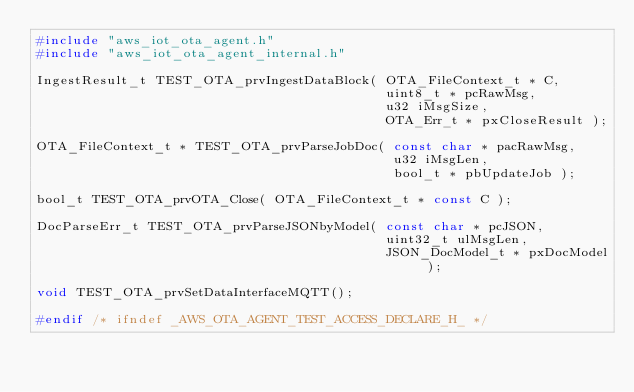Convert code to text. <code><loc_0><loc_0><loc_500><loc_500><_C_>#include "aws_iot_ota_agent.h"
#include "aws_iot_ota_agent_internal.h"

IngestResult_t TEST_OTA_prvIngestDataBlock( OTA_FileContext_t * C,
                                            uint8_t * pcRawMsg,
                                            u32 iMsgSize,
                                            OTA_Err_t * pxCloseResult );

OTA_FileContext_t * TEST_OTA_prvParseJobDoc( const char * pacRawMsg,
                                             u32 iMsgLen,
                                             bool_t * pbUpdateJob );

bool_t TEST_OTA_prvOTA_Close( OTA_FileContext_t * const C );

DocParseErr_t TEST_OTA_prvParseJSONbyModel( const char * pcJSON,
                                            uint32_t ulMsgLen,
                                            JSON_DocModel_t * pxDocModel );

void TEST_OTA_prvSetDataInterfaceMQTT();

#endif /* ifndef _AWS_OTA_AGENT_TEST_ACCESS_DECLARE_H_ */
</code> 